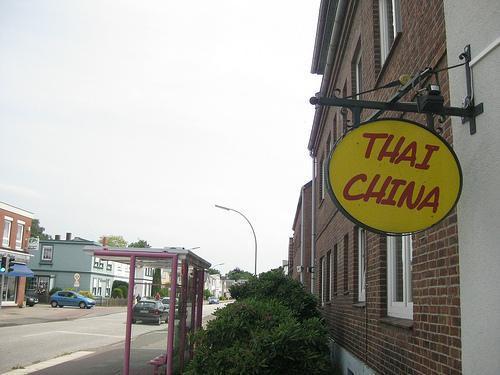How many cars are at least partially visible?
Give a very brief answer. 5. How many red bus stops are in this image?
Give a very brief answer. 1. 